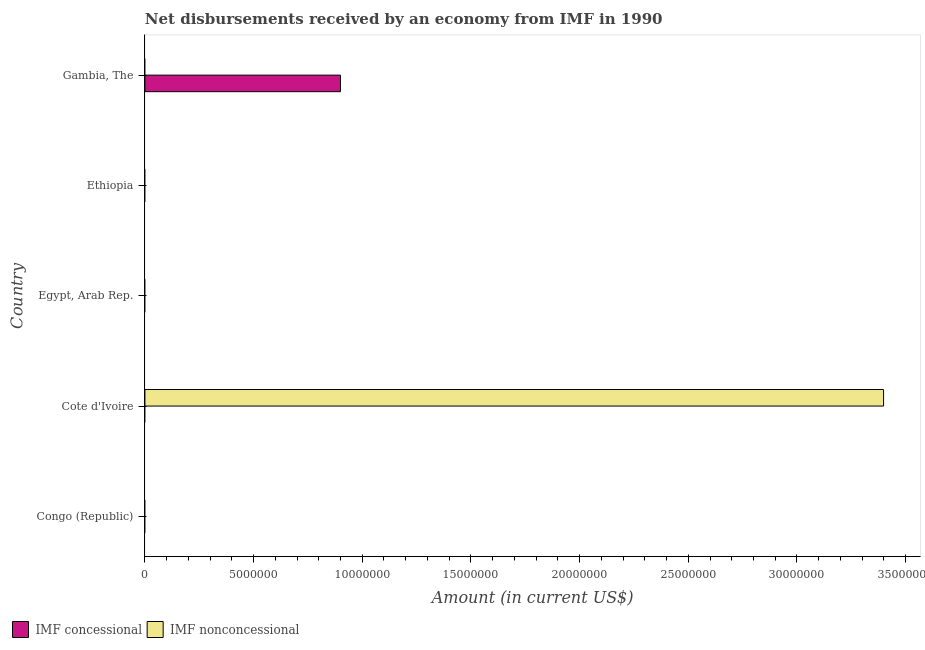How many different coloured bars are there?
Give a very brief answer. 2. Are the number of bars on each tick of the Y-axis equal?
Provide a short and direct response. No. How many bars are there on the 2nd tick from the bottom?
Give a very brief answer. 1. What is the label of the 3rd group of bars from the top?
Your answer should be very brief. Egypt, Arab Rep. What is the net non concessional disbursements from imf in Congo (Republic)?
Your answer should be very brief. 0. Across all countries, what is the maximum net non concessional disbursements from imf?
Offer a terse response. 3.40e+07. In which country was the net concessional disbursements from imf maximum?
Offer a very short reply. Gambia, The. What is the total net concessional disbursements from imf in the graph?
Your answer should be compact. 9.00e+06. What is the average net non concessional disbursements from imf per country?
Provide a succinct answer. 6.80e+06. In how many countries, is the net non concessional disbursements from imf greater than 33000000 US$?
Keep it short and to the point. 1. What is the difference between the highest and the lowest net concessional disbursements from imf?
Offer a very short reply. 9.00e+06. Are all the bars in the graph horizontal?
Offer a very short reply. Yes. How many countries are there in the graph?
Offer a terse response. 5. What is the difference between two consecutive major ticks on the X-axis?
Provide a short and direct response. 5.00e+06. How many legend labels are there?
Keep it short and to the point. 2. What is the title of the graph?
Your answer should be compact. Net disbursements received by an economy from IMF in 1990. What is the label or title of the Y-axis?
Give a very brief answer. Country. What is the Amount (in current US$) in IMF concessional in Congo (Republic)?
Give a very brief answer. 0. What is the Amount (in current US$) in IMF nonconcessional in Cote d'Ivoire?
Provide a succinct answer. 3.40e+07. What is the Amount (in current US$) of IMF concessional in Egypt, Arab Rep.?
Offer a terse response. 0. What is the Amount (in current US$) of IMF nonconcessional in Ethiopia?
Your response must be concise. 0. What is the Amount (in current US$) of IMF concessional in Gambia, The?
Your response must be concise. 9.00e+06. Across all countries, what is the maximum Amount (in current US$) of IMF concessional?
Make the answer very short. 9.00e+06. Across all countries, what is the maximum Amount (in current US$) in IMF nonconcessional?
Offer a terse response. 3.40e+07. Across all countries, what is the minimum Amount (in current US$) of IMF concessional?
Your answer should be very brief. 0. What is the total Amount (in current US$) in IMF concessional in the graph?
Ensure brevity in your answer.  9.00e+06. What is the total Amount (in current US$) of IMF nonconcessional in the graph?
Offer a terse response. 3.40e+07. What is the average Amount (in current US$) in IMF concessional per country?
Provide a short and direct response. 1.80e+06. What is the average Amount (in current US$) in IMF nonconcessional per country?
Provide a succinct answer. 6.80e+06. What is the difference between the highest and the lowest Amount (in current US$) of IMF concessional?
Your answer should be compact. 9.00e+06. What is the difference between the highest and the lowest Amount (in current US$) in IMF nonconcessional?
Your answer should be compact. 3.40e+07. 